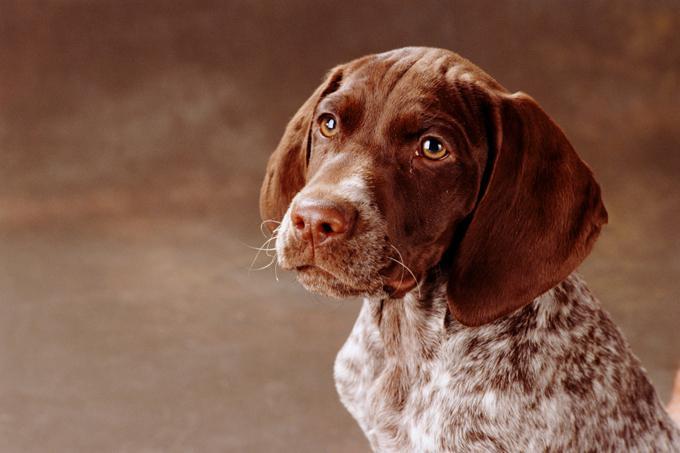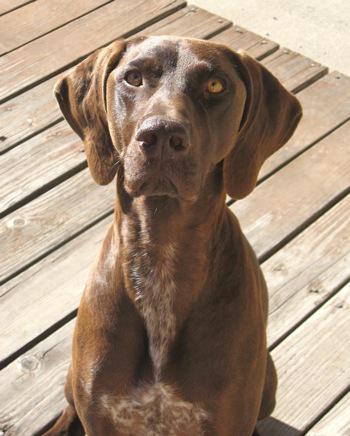The first image is the image on the left, the second image is the image on the right. For the images displayed, is the sentence "There are two dogs looking forward at the camera" factually correct? Answer yes or no. Yes. The first image is the image on the left, the second image is the image on the right. Considering the images on both sides, is "Each image contains a single dog, and each dog pictured is facing forward with its head upright and both eyes visible." valid? Answer yes or no. Yes. 